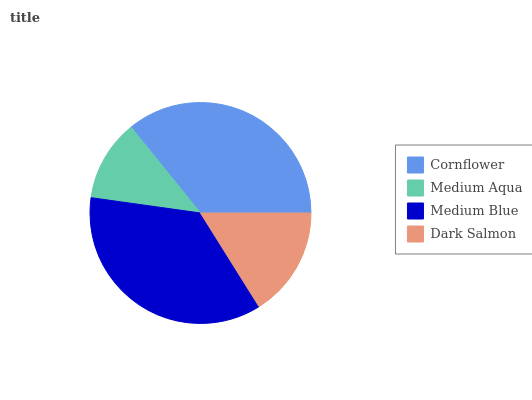Is Medium Aqua the minimum?
Answer yes or no. Yes. Is Medium Blue the maximum?
Answer yes or no. Yes. Is Medium Blue the minimum?
Answer yes or no. No. Is Medium Aqua the maximum?
Answer yes or no. No. Is Medium Blue greater than Medium Aqua?
Answer yes or no. Yes. Is Medium Aqua less than Medium Blue?
Answer yes or no. Yes. Is Medium Aqua greater than Medium Blue?
Answer yes or no. No. Is Medium Blue less than Medium Aqua?
Answer yes or no. No. Is Cornflower the high median?
Answer yes or no. Yes. Is Dark Salmon the low median?
Answer yes or no. Yes. Is Medium Aqua the high median?
Answer yes or no. No. Is Medium Blue the low median?
Answer yes or no. No. 